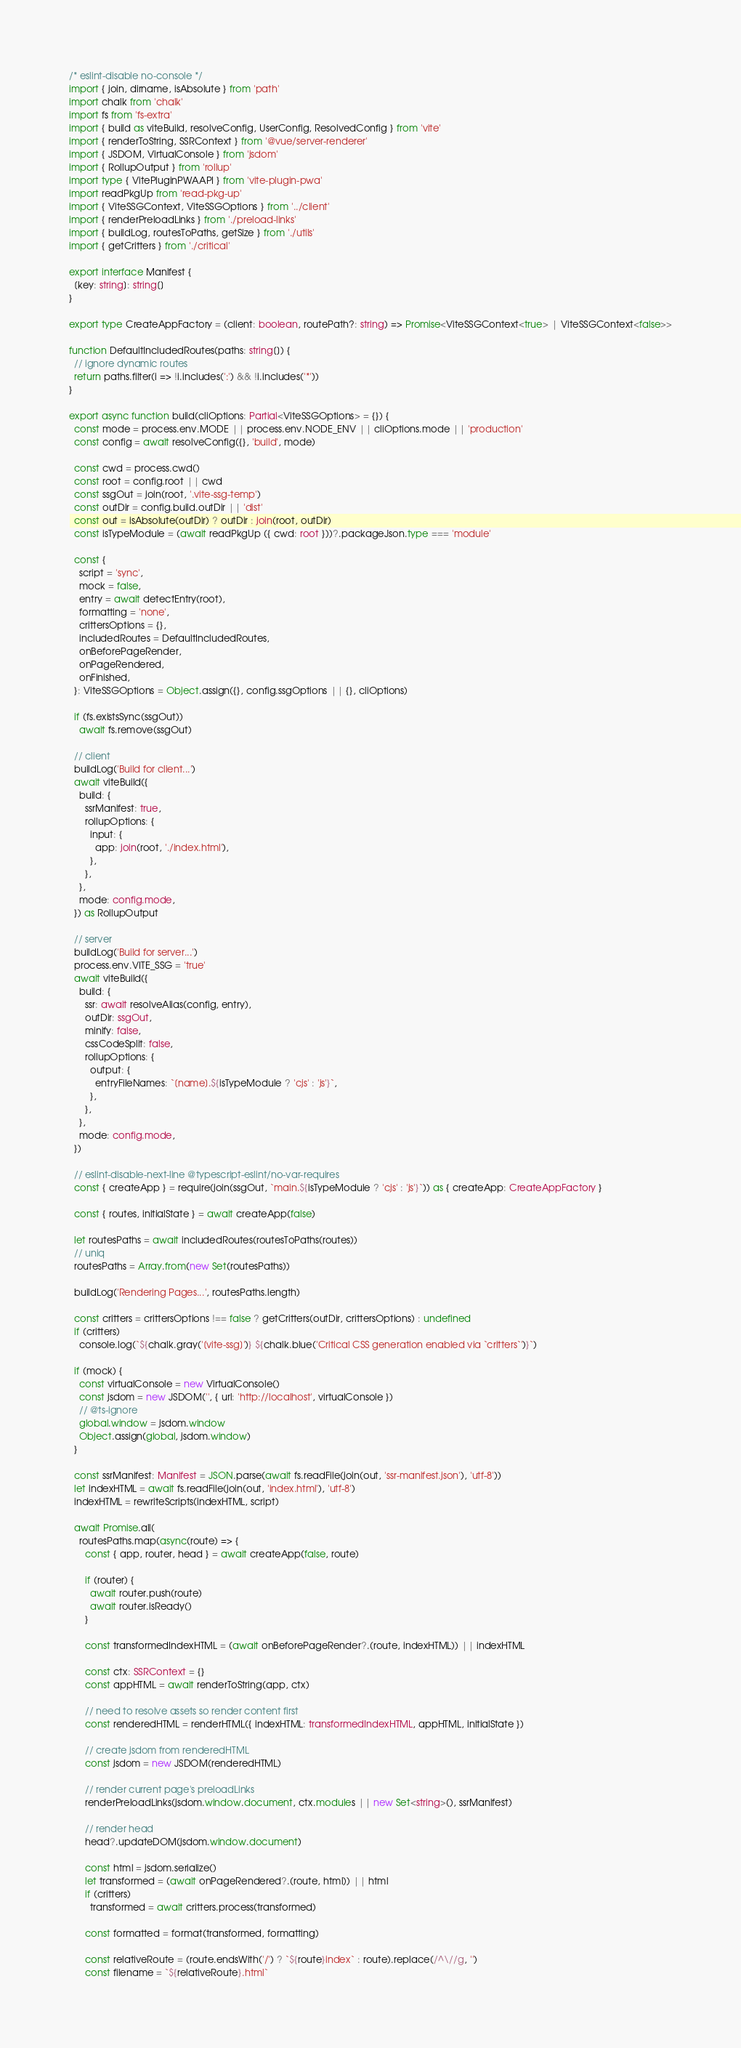Convert code to text. <code><loc_0><loc_0><loc_500><loc_500><_TypeScript_>/* eslint-disable no-console */
import { join, dirname, isAbsolute } from 'path'
import chalk from 'chalk'
import fs from 'fs-extra'
import { build as viteBuild, resolveConfig, UserConfig, ResolvedConfig } from 'vite'
import { renderToString, SSRContext } from '@vue/server-renderer'
import { JSDOM, VirtualConsole } from 'jsdom'
import { RollupOutput } from 'rollup'
import type { VitePluginPWAAPI } from 'vite-plugin-pwa'
import readPkgUp from 'read-pkg-up'
import { ViteSSGContext, ViteSSGOptions } from '../client'
import { renderPreloadLinks } from './preload-links'
import { buildLog, routesToPaths, getSize } from './utils'
import { getCritters } from './critical'

export interface Manifest {
  [key: string]: string[]
}

export type CreateAppFactory = (client: boolean, routePath?: string) => Promise<ViteSSGContext<true> | ViteSSGContext<false>>

function DefaultIncludedRoutes(paths: string[]) {
  // ignore dynamic routes
  return paths.filter(i => !i.includes(':') && !i.includes('*'))
}

export async function build(cliOptions: Partial<ViteSSGOptions> = {}) {
  const mode = process.env.MODE || process.env.NODE_ENV || cliOptions.mode || 'production'
  const config = await resolveConfig({}, 'build', mode)

  const cwd = process.cwd()
  const root = config.root || cwd
  const ssgOut = join(root, '.vite-ssg-temp')
  const outDir = config.build.outDir || 'dist'
  const out = isAbsolute(outDir) ? outDir : join(root, outDir)
  const isTypeModule = (await readPkgUp ({ cwd: root }))?.packageJson.type === 'module'

  const {
    script = 'sync',
    mock = false,
    entry = await detectEntry(root),
    formatting = 'none',
    crittersOptions = {},
    includedRoutes = DefaultIncludedRoutes,
    onBeforePageRender,
    onPageRendered,
    onFinished,
  }: ViteSSGOptions = Object.assign({}, config.ssgOptions || {}, cliOptions)

  if (fs.existsSync(ssgOut))
    await fs.remove(ssgOut)

  // client
  buildLog('Build for client...')
  await viteBuild({
    build: {
      ssrManifest: true,
      rollupOptions: {
        input: {
          app: join(root, './index.html'),
        },
      },
    },
    mode: config.mode,
  }) as RollupOutput

  // server
  buildLog('Build for server...')
  process.env.VITE_SSG = 'true'
  await viteBuild({
    build: {
      ssr: await resolveAlias(config, entry),
      outDir: ssgOut,
      minify: false,
      cssCodeSplit: false,
      rollupOptions: {
        output: {
          entryFileNames: `[name].${isTypeModule ? 'cjs' : 'js'}`,
        },
      },
    },
    mode: config.mode,
  })

  // eslint-disable-next-line @typescript-eslint/no-var-requires
  const { createApp } = require(join(ssgOut, `main.${isTypeModule ? 'cjs' : 'js'}`)) as { createApp: CreateAppFactory }

  const { routes, initialState } = await createApp(false)

  let routesPaths = await includedRoutes(routesToPaths(routes))
  // uniq
  routesPaths = Array.from(new Set(routesPaths))

  buildLog('Rendering Pages...', routesPaths.length)

  const critters = crittersOptions !== false ? getCritters(outDir, crittersOptions) : undefined
  if (critters)
    console.log(`${chalk.gray('[vite-ssg]')} ${chalk.blue('Critical CSS generation enabled via `critters`')}`)

  if (mock) {
    const virtualConsole = new VirtualConsole()
    const jsdom = new JSDOM('', { url: 'http://localhost', virtualConsole })
    // @ts-ignore
    global.window = jsdom.window
    Object.assign(global, jsdom.window)
  }

  const ssrManifest: Manifest = JSON.parse(await fs.readFile(join(out, 'ssr-manifest.json'), 'utf-8'))
  let indexHTML = await fs.readFile(join(out, 'index.html'), 'utf-8')
  indexHTML = rewriteScripts(indexHTML, script)

  await Promise.all(
    routesPaths.map(async(route) => {
      const { app, router, head } = await createApp(false, route)

      if (router) {
        await router.push(route)
        await router.isReady()
      }

      const transformedIndexHTML = (await onBeforePageRender?.(route, indexHTML)) || indexHTML

      const ctx: SSRContext = {}
      const appHTML = await renderToString(app, ctx)

      // need to resolve assets so render content first
      const renderedHTML = renderHTML({ indexHTML: transformedIndexHTML, appHTML, initialState })

      // create jsdom from renderedHTML
      const jsdom = new JSDOM(renderedHTML)

      // render current page's preloadLinks
      renderPreloadLinks(jsdom.window.document, ctx.modules || new Set<string>(), ssrManifest)

      // render head
      head?.updateDOM(jsdom.window.document)

      const html = jsdom.serialize()
      let transformed = (await onPageRendered?.(route, html)) || html
      if (critters)
        transformed = await critters.process(transformed)

      const formatted = format(transformed, formatting)

      const relativeRoute = (route.endsWith('/') ? `${route}index` : route).replace(/^\//g, '')
      const filename = `${relativeRoute}.html`
</code> 